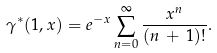Convert formula to latex. <formula><loc_0><loc_0><loc_500><loc_500>\gamma ^ { * } ( 1 , x ) = e ^ { - x } \sum _ { n = 0 } ^ { \infty } \frac { x ^ { n } } { ( n \, + \, 1 ) ! } .</formula> 